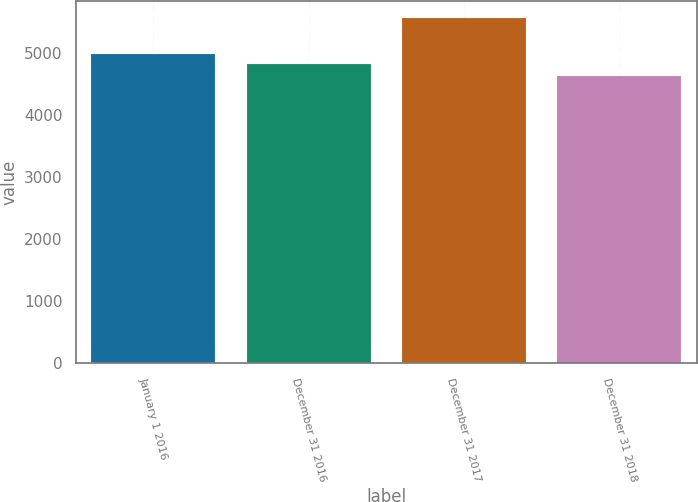Convert chart to OTSL. <chart><loc_0><loc_0><loc_500><loc_500><bar_chart><fcel>January 1 2016<fcel>December 31 2016<fcel>December 31 2017<fcel>December 31 2018<nl><fcel>4983<fcel>4828<fcel>5557<fcel>4630<nl></chart> 